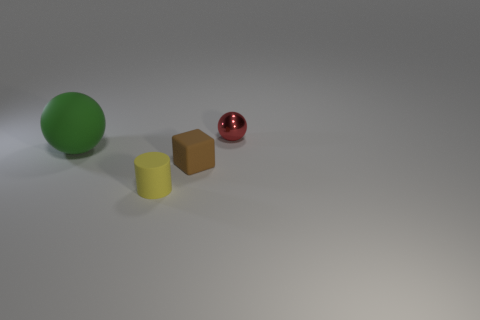Add 2 small brown matte objects. How many objects exist? 6 Subtract all cylinders. How many objects are left? 3 Add 1 matte cubes. How many matte cubes are left? 2 Add 2 metallic cylinders. How many metallic cylinders exist? 2 Subtract 0 blue cylinders. How many objects are left? 4 Subtract all red blocks. Subtract all red cylinders. How many blocks are left? 1 Subtract all blue cylinders. How many green spheres are left? 1 Subtract all green metal blocks. Subtract all small metallic balls. How many objects are left? 3 